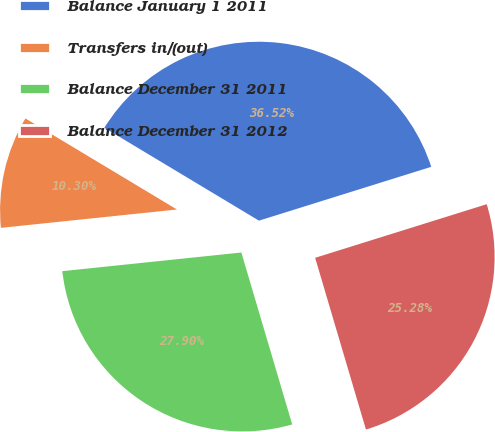Convert chart. <chart><loc_0><loc_0><loc_500><loc_500><pie_chart><fcel>Balance January 1 2011<fcel>Transfers in/(out)<fcel>Balance December 31 2011<fcel>Balance December 31 2012<nl><fcel>36.52%<fcel>10.3%<fcel>27.9%<fcel>25.28%<nl></chart> 